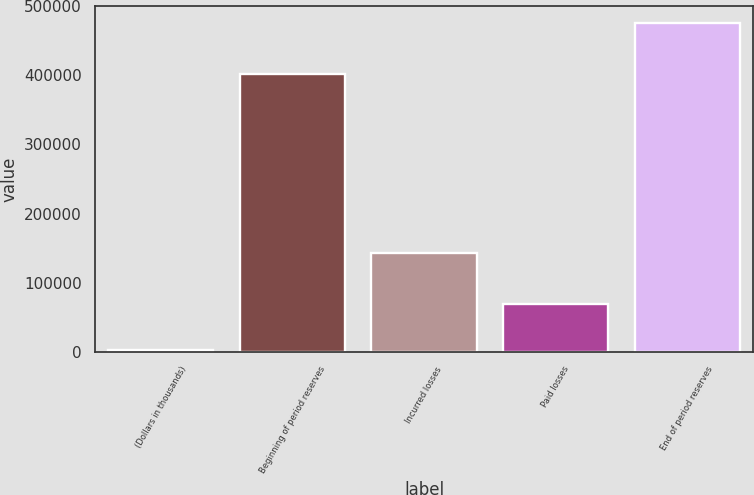Convert chart. <chart><loc_0><loc_0><loc_500><loc_500><bar_chart><fcel>(Dollars in thousands)<fcel>Beginning of period reserves<fcel>Incurred losses<fcel>Paid losses<fcel>End of period reserves<nl><fcel>2014<fcel>402461<fcel>142233<fcel>68489<fcel>476205<nl></chart> 